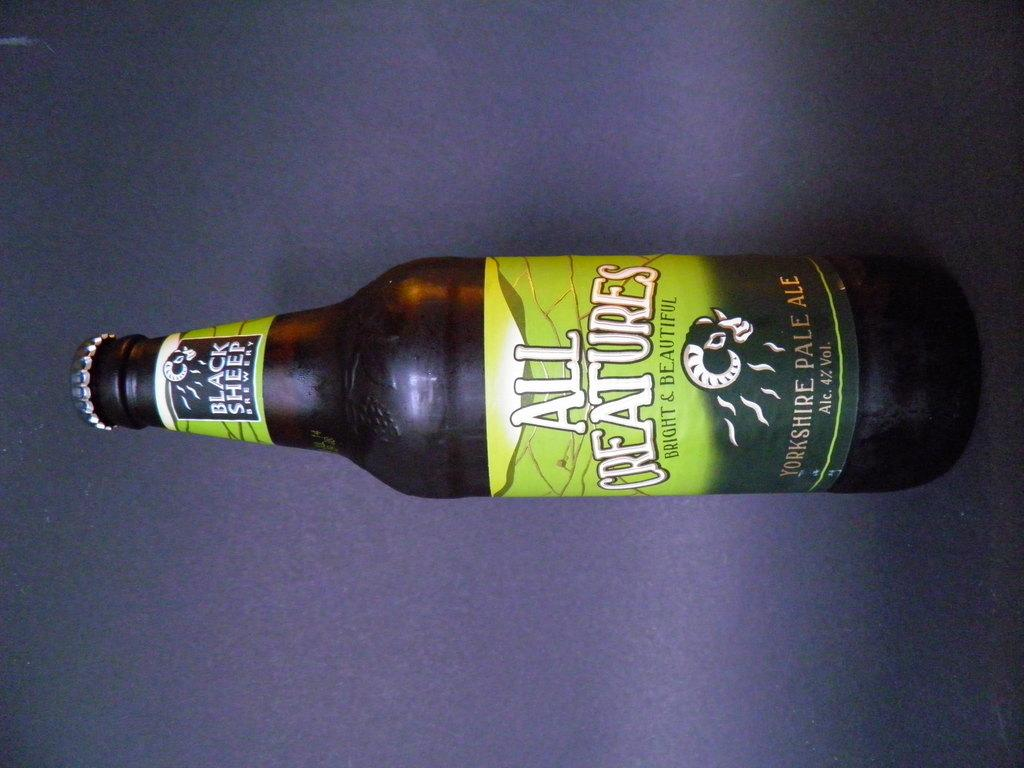<image>
Provide a brief description of the given image. A sideways bottle of Black sheep all creatures ale. 